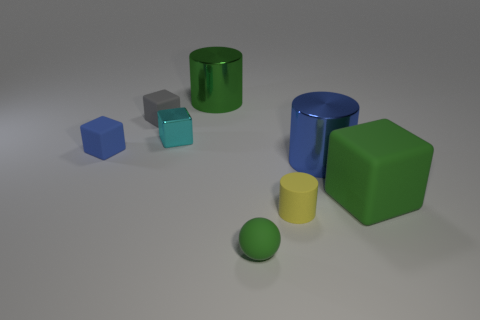Add 1 tiny yellow rubber things. How many objects exist? 9 Subtract all balls. How many objects are left? 7 Subtract 0 gray cylinders. How many objects are left? 8 Subtract all big blocks. Subtract all blue metal balls. How many objects are left? 7 Add 2 small cubes. How many small cubes are left? 5 Add 8 blue matte cubes. How many blue matte cubes exist? 9 